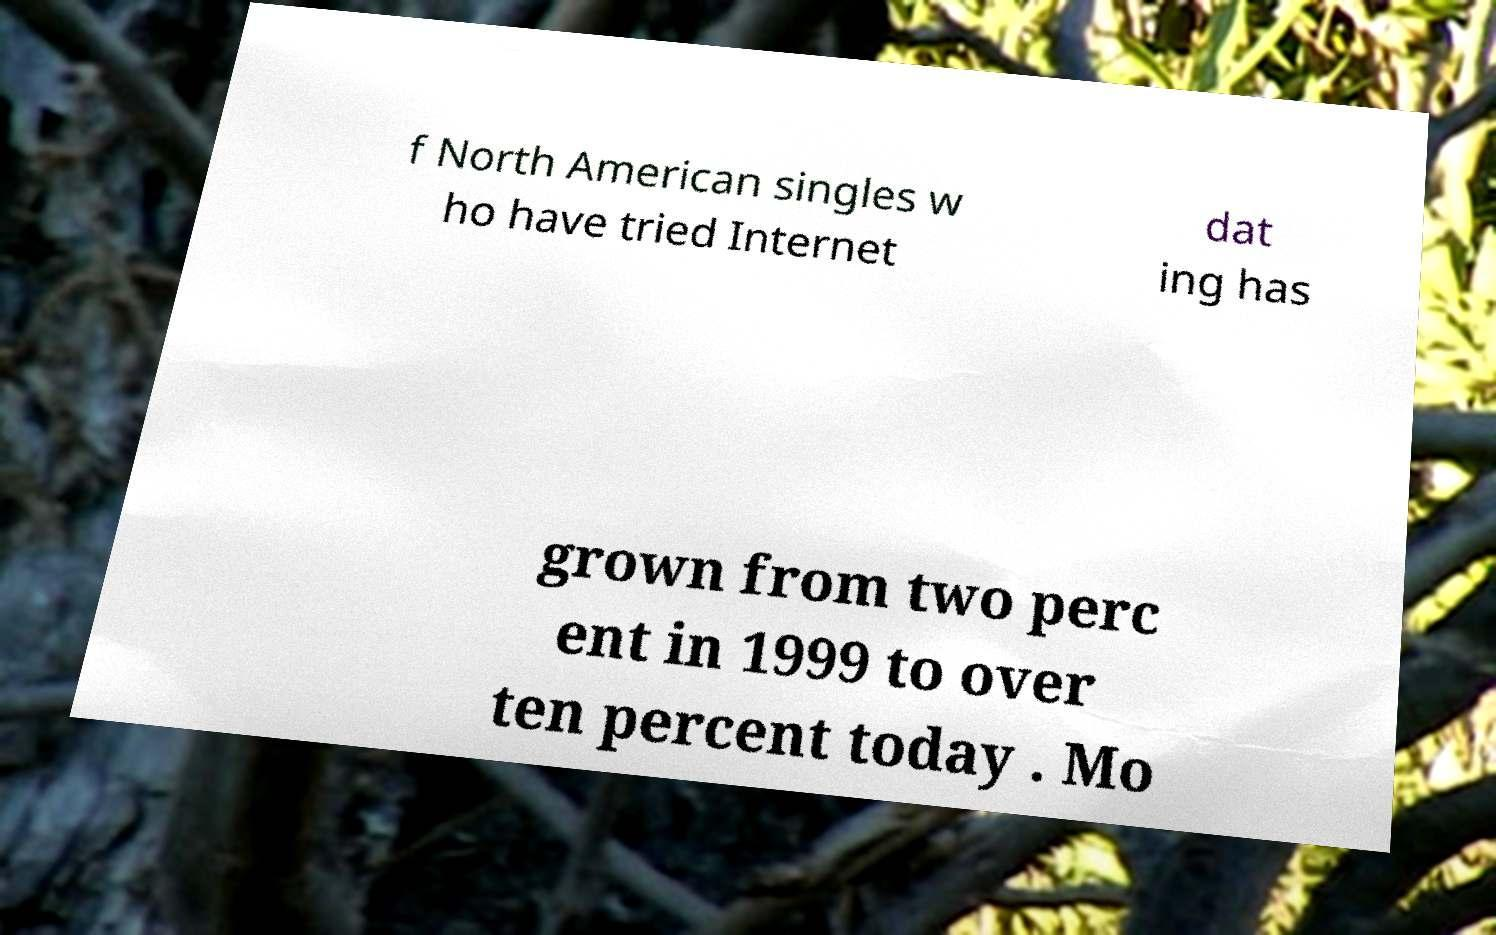There's text embedded in this image that I need extracted. Can you transcribe it verbatim? f North American singles w ho have tried Internet dat ing has grown from two perc ent in 1999 to over ten percent today . Mo 